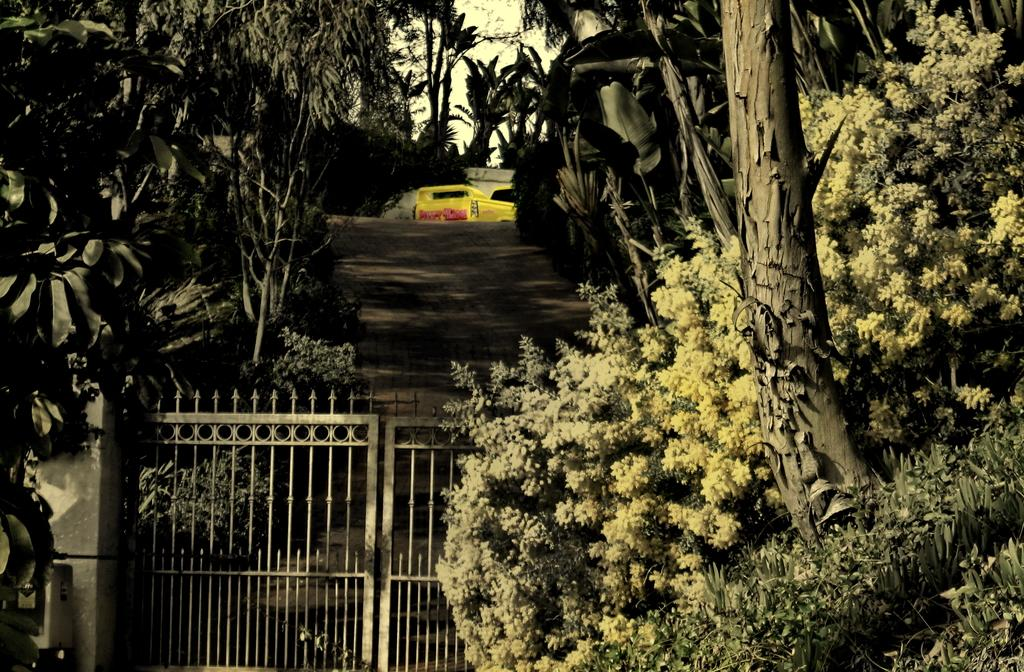What type of structure is located in the image? There is an iron gate in the image. What can be seen on either side of the gate? There are trees on both the left and right sides of the gate. What might be located behind the gate? There appears to be a vehicle behind the gate. What is visible in the background of the image? The sky is visible in the image. How does the net catch the fish in the image? There is no net or fish present in the image; it features an iron gate with trees and a vehicle in the background. 